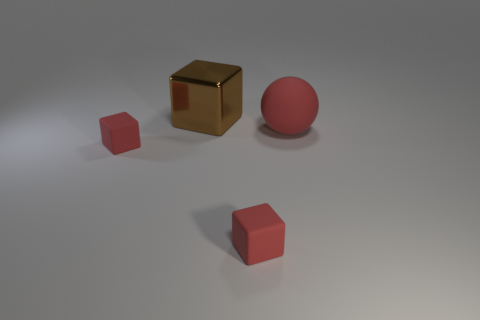Is there anything else that is made of the same material as the big block?
Your answer should be very brief. No. There is a tiny cube to the left of the red block in front of the tiny cube to the left of the big brown object; what is it made of?
Offer a terse response. Rubber. How many other objects are the same size as the red ball?
Ensure brevity in your answer.  1. How many small red blocks are to the left of the tiny thing that is on the right side of the large object that is behind the large red matte thing?
Keep it short and to the point. 1. There is a block behind the small matte block that is to the left of the big metallic block; what is its material?
Give a very brief answer. Metal. Are there any other large brown objects of the same shape as the large brown shiny thing?
Provide a short and direct response. No. There is a matte object that is the same size as the brown block; what color is it?
Offer a terse response. Red. How many things are either red spheres that are to the right of the shiny block or red cubes that are to the right of the brown cube?
Give a very brief answer. 2. How many things are tiny red blocks or big brown metallic cubes?
Provide a succinct answer. 3. How many big blocks are the same material as the large brown object?
Keep it short and to the point. 0. 